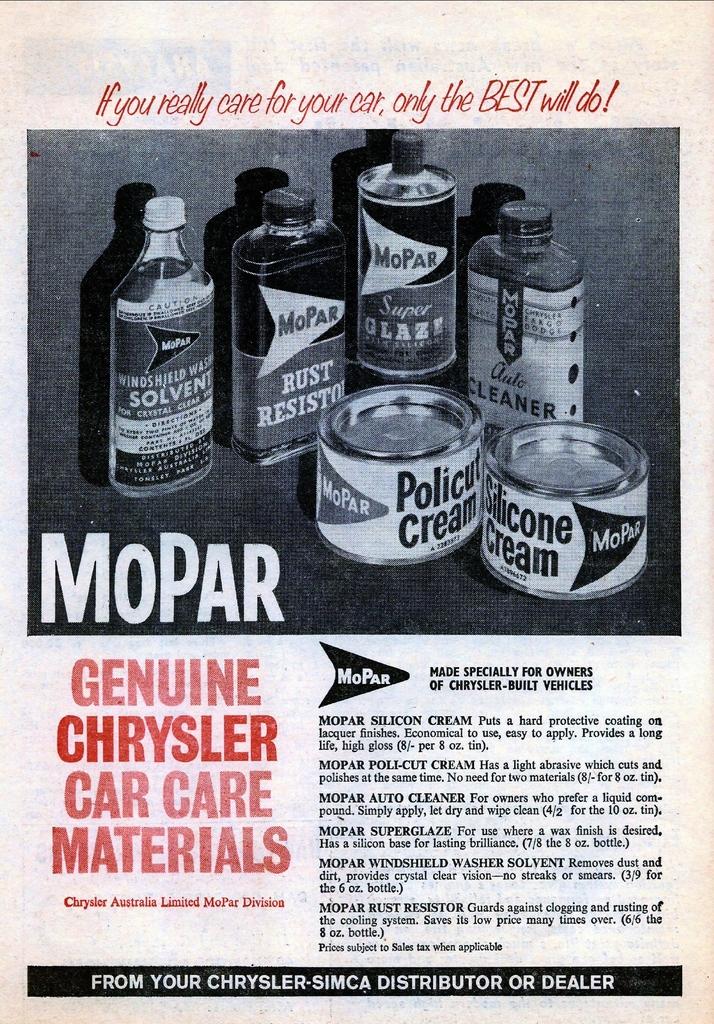What is the brand of car care materials?
Offer a terse response. Mopar. What type of cream is on the small can on the right?
Give a very brief answer. Silicone. 